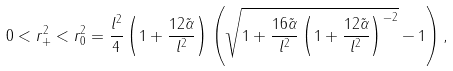<formula> <loc_0><loc_0><loc_500><loc_500>0 < r _ { + } ^ { 2 } < r _ { 0 } ^ { 2 } = \frac { l ^ { 2 } } { 4 } \left ( 1 + \frac { 1 2 \tilde { \alpha } } { l ^ { 2 } } \right ) \left ( \sqrt { 1 + \frac { 1 6 \tilde { \alpha } } { l ^ { 2 } } \left ( 1 + \frac { 1 2 \tilde { \alpha } } { l ^ { 2 } } \right ) ^ { - 2 } } - 1 \right ) ,</formula> 